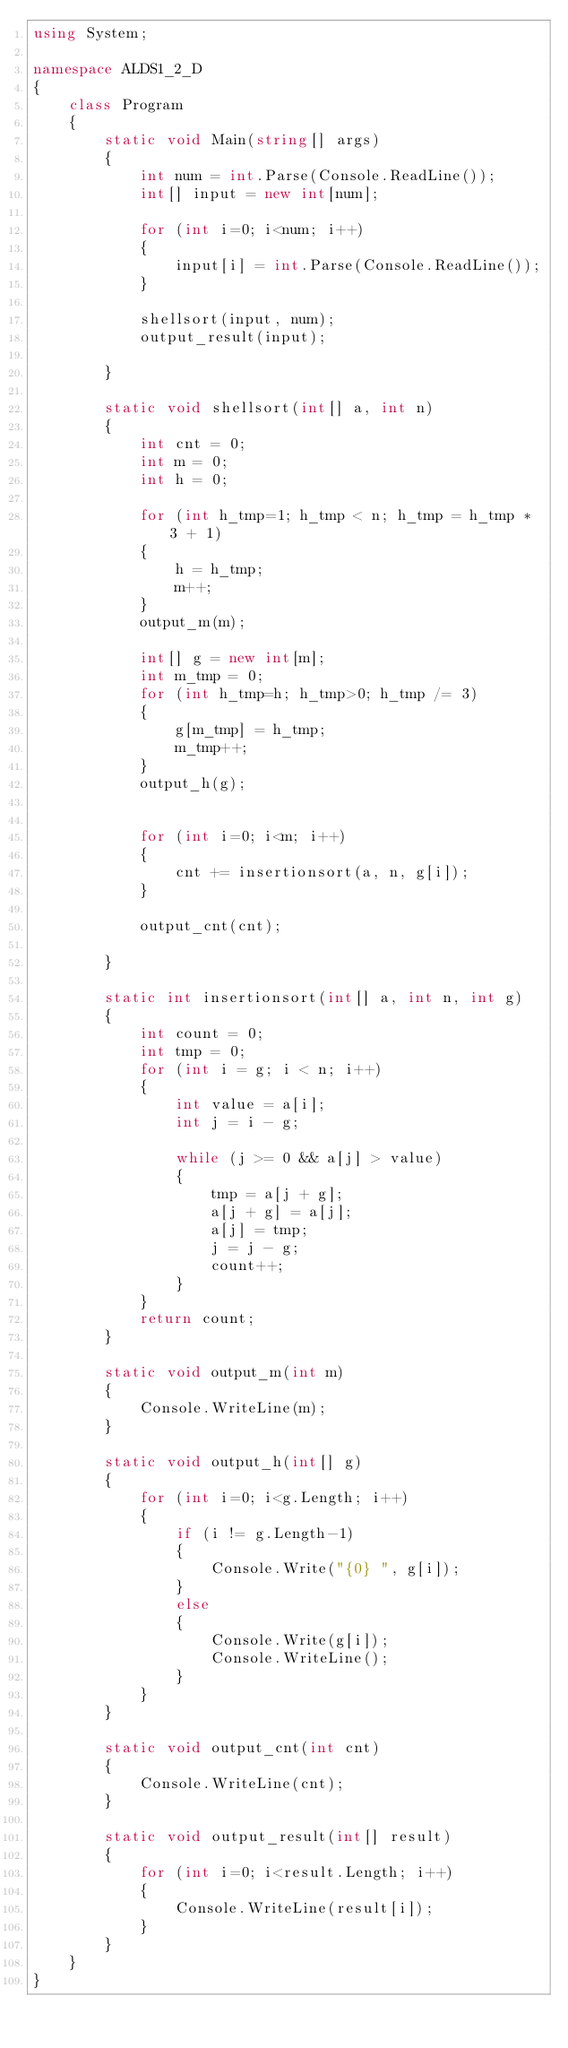<code> <loc_0><loc_0><loc_500><loc_500><_C#_>using System;

namespace ALDS1_2_D
{
    class Program
    {
        static void Main(string[] args)
        {
            int num = int.Parse(Console.ReadLine());
            int[] input = new int[num];

            for (int i=0; i<num; i++)
            {
                input[i] = int.Parse(Console.ReadLine());
            }

            shellsort(input, num);
            output_result(input);

        }

        static void shellsort(int[] a, int n)
        {
            int cnt = 0;
            int m = 0;
            int h = 0;

            for (int h_tmp=1; h_tmp < n; h_tmp = h_tmp * 3 + 1)
            {
                h = h_tmp;
                m++;
            }
            output_m(m);

            int[] g = new int[m];
            int m_tmp = 0;
            for (int h_tmp=h; h_tmp>0; h_tmp /= 3)
            {
                g[m_tmp] = h_tmp;
                m_tmp++;
            }
            output_h(g);


            for (int i=0; i<m; i++)
            {
                cnt += insertionsort(a, n, g[i]);
            }

            output_cnt(cnt);

        }

        static int insertionsort(int[] a, int n, int g)
        {
            int count = 0;
            int tmp = 0;
            for (int i = g; i < n; i++)
            {
                int value = a[i];
                int j = i - g;

                while (j >= 0 && a[j] > value)
                {
                    tmp = a[j + g];
                    a[j + g] = a[j];
                    a[j] = tmp;
                    j = j - g;
                    count++;
                }
            }
            return count;
        }

        static void output_m(int m)
        {
            Console.WriteLine(m);
        }

        static void output_h(int[] g)
        {
            for (int i=0; i<g.Length; i++)
            {
                if (i != g.Length-1)
                {
                    Console.Write("{0} ", g[i]);
                }
                else
                {
                    Console.Write(g[i]);
                    Console.WriteLine();
                }
            }
        }

        static void output_cnt(int cnt)
        {
            Console.WriteLine(cnt);
        }

        static void output_result(int[] result)
        {
            for (int i=0; i<result.Length; i++)
            {
                Console.WriteLine(result[i]);
            }
        }
    }
}</code> 